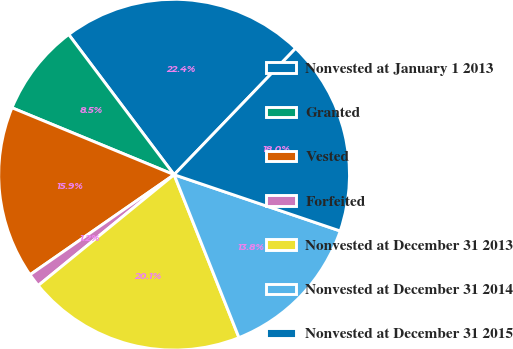Convert chart. <chart><loc_0><loc_0><loc_500><loc_500><pie_chart><fcel>Nonvested at January 1 2013<fcel>Granted<fcel>Vested<fcel>Forfeited<fcel>Nonvested at December 31 2013<fcel>Nonvested at December 31 2014<fcel>Nonvested at December 31 2015<nl><fcel>22.45%<fcel>8.51%<fcel>15.89%<fcel>1.23%<fcel>20.14%<fcel>13.77%<fcel>18.01%<nl></chart> 